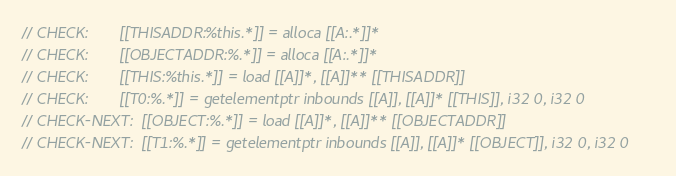Convert code to text. <code><loc_0><loc_0><loc_500><loc_500><_ObjectiveC_>// CHECK:       [[THISADDR:%this.*]] = alloca [[A:.*]]*
// CHECK:       [[OBJECTADDR:%.*]] = alloca [[A:.*]]*
// CHECK:       [[THIS:%this.*]] = load [[A]]*, [[A]]** [[THISADDR]]
// CHECK:       [[T0:%.*]] = getelementptr inbounds [[A]], [[A]]* [[THIS]], i32 0, i32 0
// CHECK-NEXT:  [[OBJECT:%.*]] = load [[A]]*, [[A]]** [[OBJECTADDR]]
// CHECK-NEXT:  [[T1:%.*]] = getelementptr inbounds [[A]], [[A]]* [[OBJECT]], i32 0, i32 0</code> 